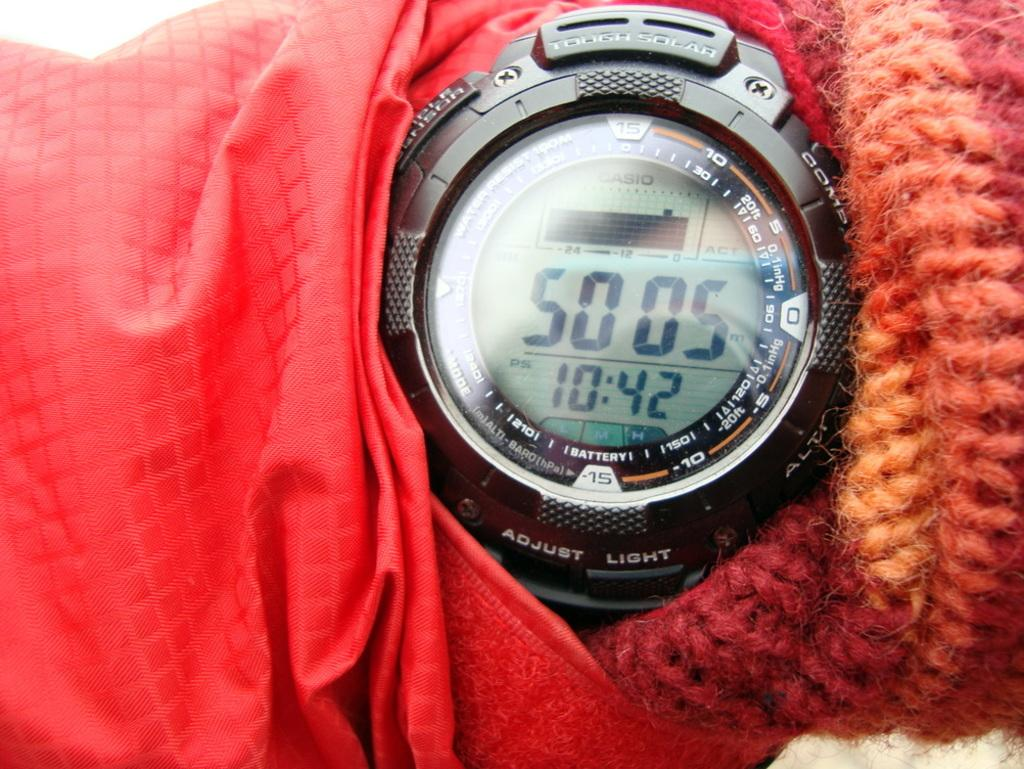What type of accessory is present in the image? There is a hand watch in the picture. What is the color of the hand watch? The hand watch is black in color. What can be seen on the left side of the image? There is a red color cloth on the left side of the image. What is present on the right side of the image? There is a red color thread on the right side of the image. How many eyes can be seen on the hand watch in the image? There are no eyes present on the hand watch in the image. 